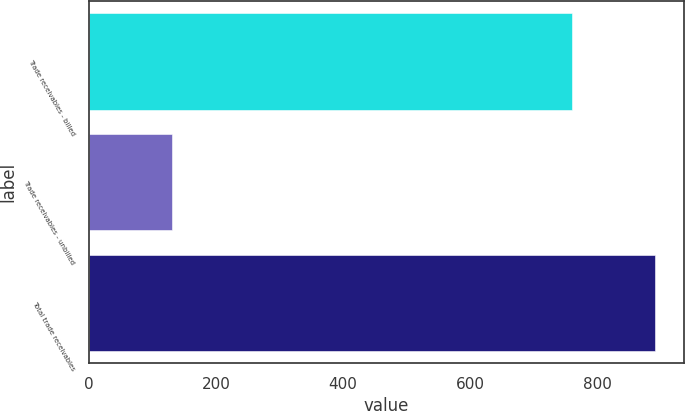Convert chart. <chart><loc_0><loc_0><loc_500><loc_500><bar_chart><fcel>Trade receivables - billed<fcel>Trade receivables - unbilled<fcel>Total trade receivables<nl><fcel>760.8<fcel>130.8<fcel>891.6<nl></chart> 